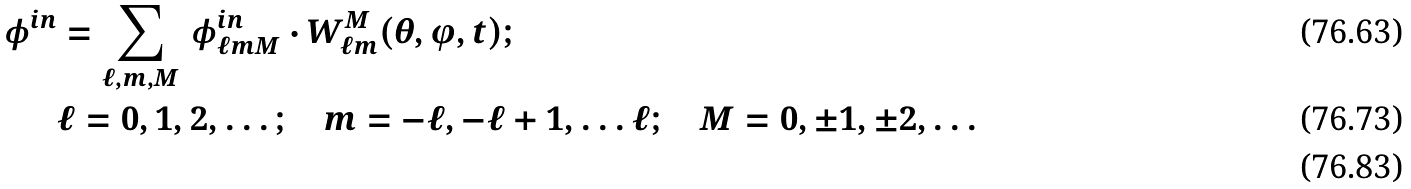Convert formula to latex. <formula><loc_0><loc_0><loc_500><loc_500>\phi ^ { i n } & = \sum _ { \ell , m , M } \, \phi _ { \ell m M } ^ { i n } \cdot W _ { \ell m } ^ { M } ( \theta , \varphi , t ) ; \\ & \ell = 0 , 1 , 2 , \dots ; \quad m = - \ell , - \ell + 1 , \dots \ell ; \quad M = 0 , \pm 1 , \pm 2 , \dots \\</formula> 